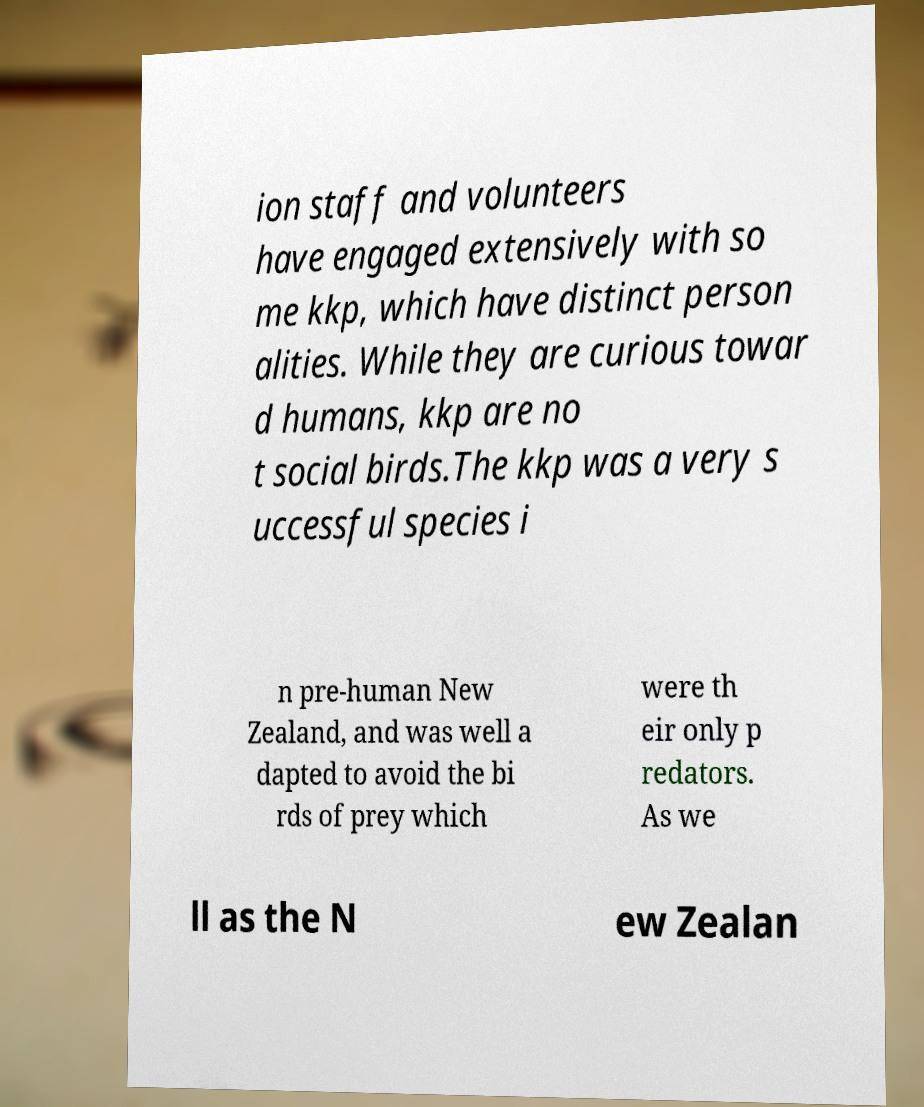Can you read and provide the text displayed in the image?This photo seems to have some interesting text. Can you extract and type it out for me? ion staff and volunteers have engaged extensively with so me kkp, which have distinct person alities. While they are curious towar d humans, kkp are no t social birds.The kkp was a very s uccessful species i n pre-human New Zealand, and was well a dapted to avoid the bi rds of prey which were th eir only p redators. As we ll as the N ew Zealan 